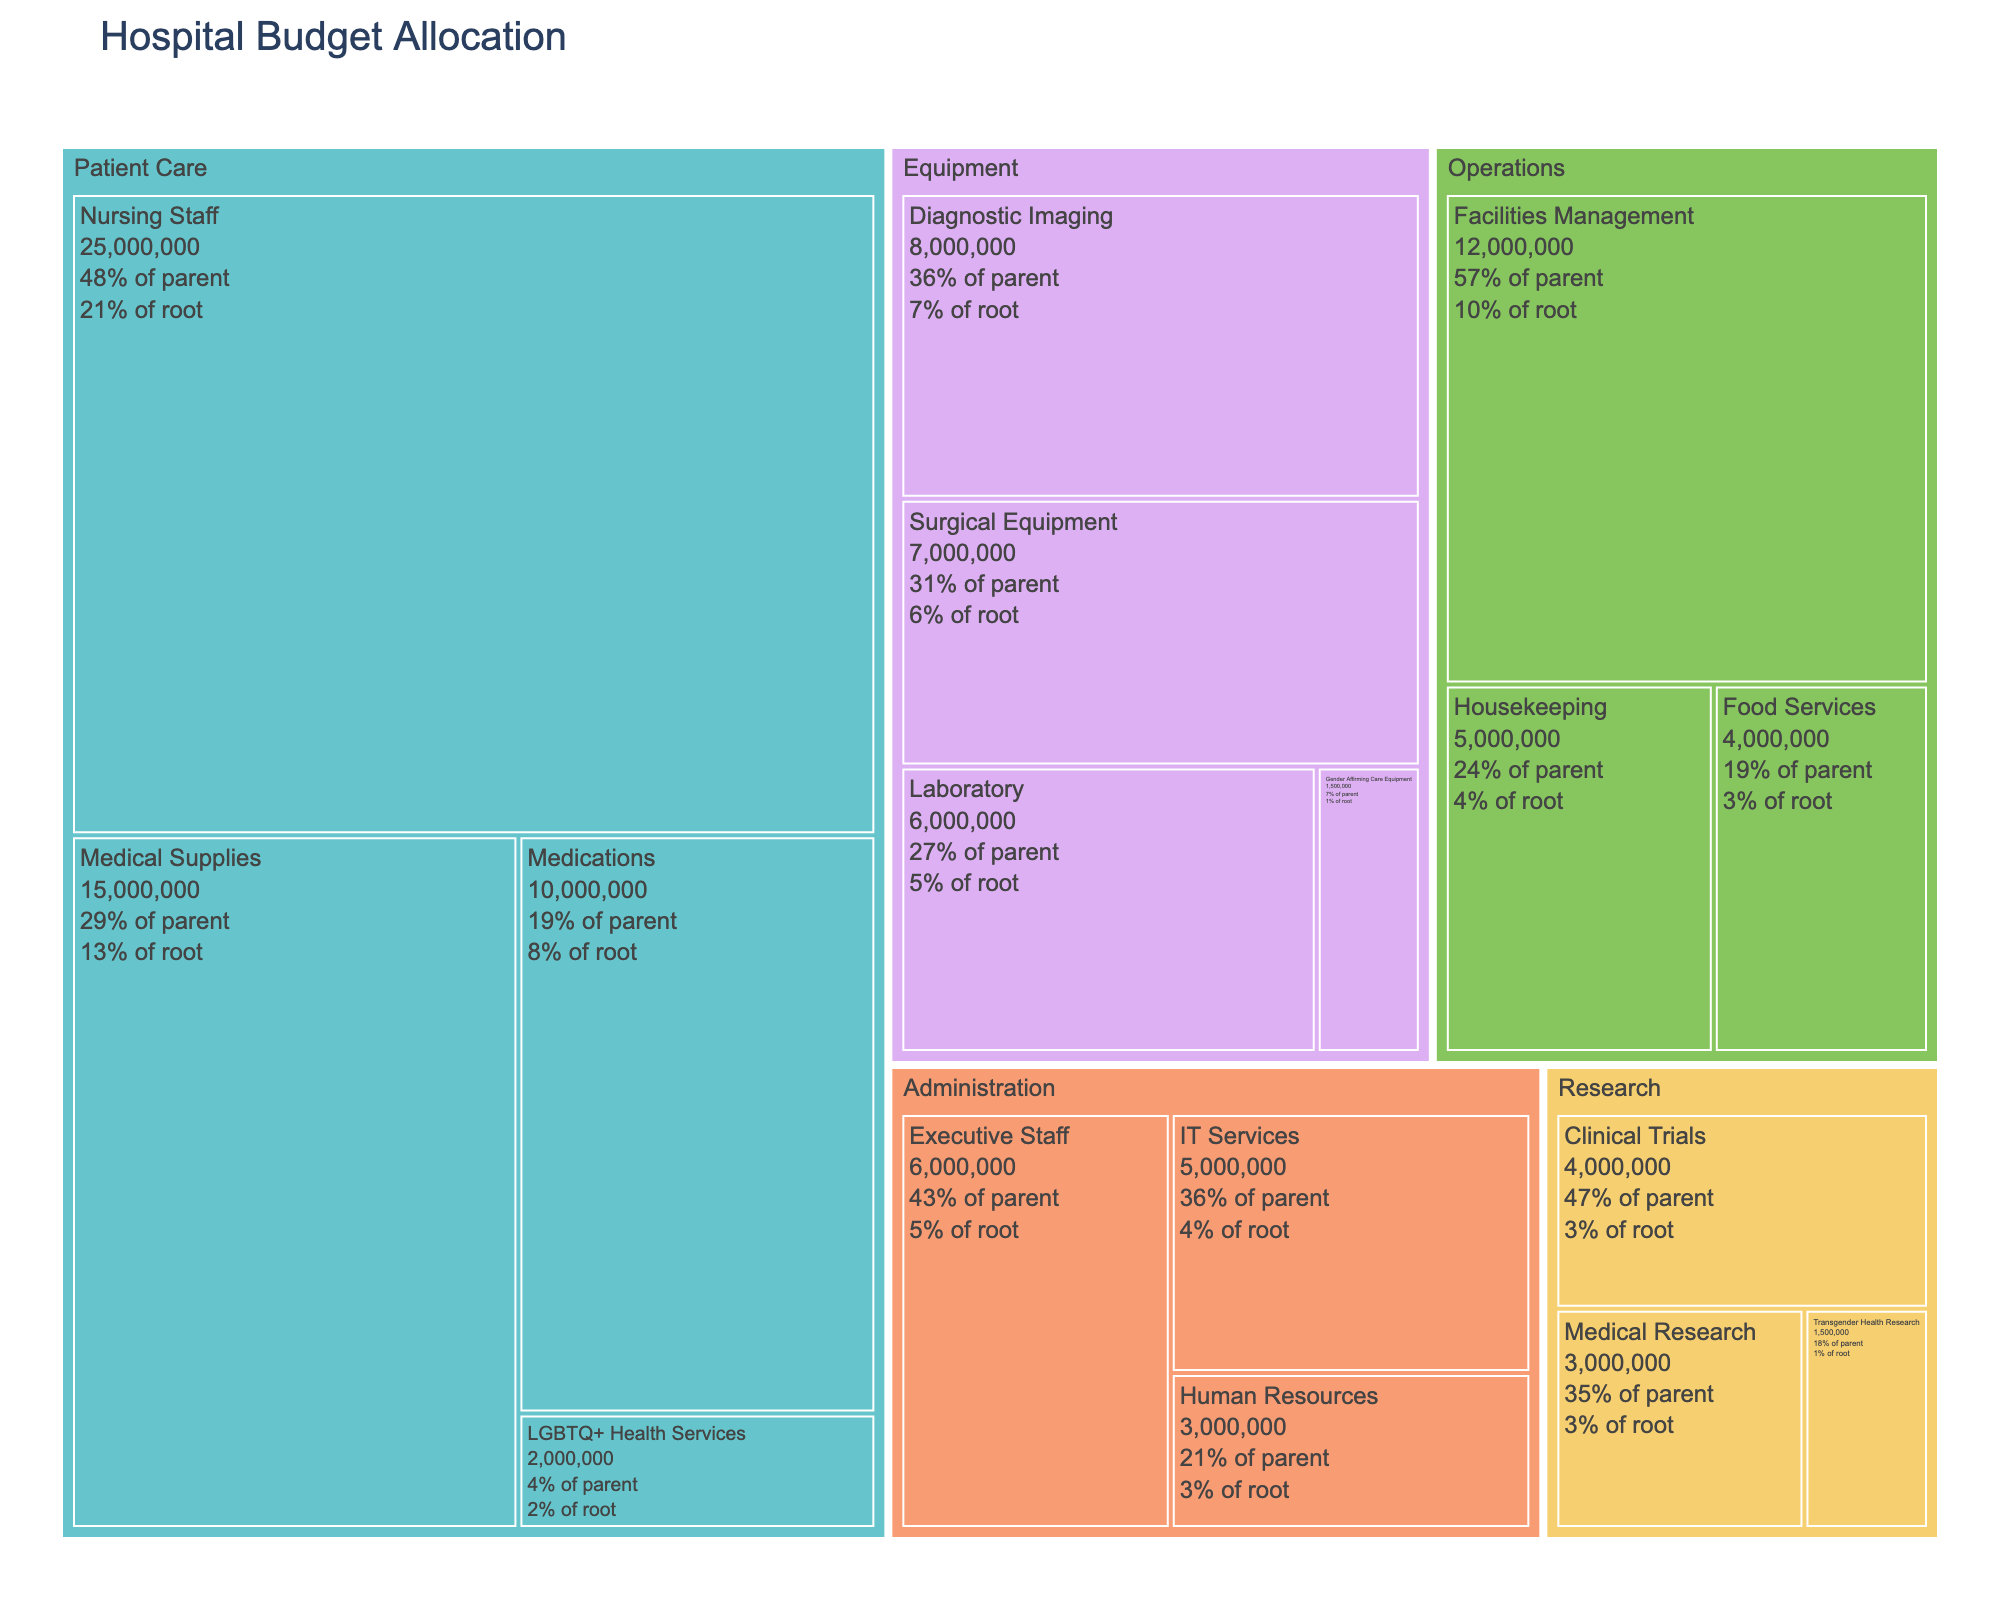What is the total budget allocated to the Patient Care department? The treemap shows the individual budgets for the Patient Care department's categories. Summing the values for Nursing Staff ($25,000,000), Medical Supplies ($15,000,000), Medications ($10,000,000), and LGBTQ+ Health Services ($2,000,000) gives the total budget.
Answer: $52,000,000 Which department has the largest single category allocation? From the treemap, the largest single category allocation is found in the Patient Care department under Nursing Staff, which has a budget of $25,000,000.
Answer: Patient Care (Nursing Staff) How does the budget for LGBTQ+ Health Services compare to that for Gender Affirming Care Equipment? The budget for LGBTQ+ Health Services is $2,000,000, and for Gender Affirming Care Equipment is $1,500,000. Comparing these, LGBTQ+ Health Services has a higher budget.
Answer: LGBTQ+ Health Services has a higher budget What percentage of the Equipment department's budget is allocated to Diagnostic Imaging? The Equipment department has the following allocations: Diagnostic Imaging ($8,000,000), Laboratory ($6,000,000), Surgical Equipment ($7,000,000), and Gender Affirming Care Equipment ($1,500,000). The total budget for Equipment is $22,500,000. The percentage for Diagnostic Imaging is calculated as ($8,000,000 / $22,500,000) ≈ 35.6%.
Answer: 35.6% What is the combined budget for Research and Administration departments? Adding the budgets for the categories within these departments, Research has Clinical Trials ($4,000,000), Medical Research ($3,000,000), and Transgender Health Research ($1,500,000) totaling $8,500,000. Administration has Executive Staff ($6,000,000), Human Resources ($3,000,000), and IT Services ($5,000,000) totaling $14,000,000. The combined budget is $8,500,000 + $14,000,000 = $22,500,000.
Answer: $22,500,000 Which budget is greater: Medical Supplies or Facilities Management? The treemap shows Medical Supplies with a budget of $15,000,000 and Facilities Management with a budget of $12,000,000. Comparing these, Medical Supplies has a greater budget.
Answer: Medical Supplies What percentage of the total hospital budget is allocated to Operations? The Operations department has allocations for Facilities Management ($12,000,000), Housekeeping ($5,000,000), and Food Services ($4,000,000). The total Operations budget is $21,000,000. Summing all department budgets gives the total hospital budget: $25,000,000 + $15,000,000 + $10,000,000 + $2,000,000 + $12,000,000 + $5,000,000 + $4,000,000 + $8,000,000 + $6,000,000 + $7,000,000 + $1,500,000 + $6,000,000 + $3,000,000 + $5,000,000 + $4,000,000 + $3,000,000 + $1,500,000 = $122,000,000. The percentage for Operations is ($21,000,000 / $122,000,000) ≈ 17.2%.
Answer: 17.2% How does the budget for Patient Care compare to the combined budget for Equipment and Administration? The Patient Care budget is $52,000,000. The combined budget for Equipment ($22,500,000) and Administration ($14,000,000) is $22,500,000 + $14,000,000 = $36,500,000. Patient Care has a higher budget.
Answer: Patient Care has a higher budget What is the total budget allocated for the nursing staff within the hospital budget? The treemap shows the budget specifically for Nursing Staff under Patient Care, which is $25,000,000.
Answer: $25,000,000 